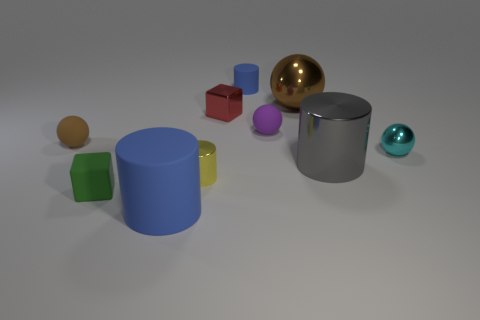Subtract all red cylinders. Subtract all cyan spheres. How many cylinders are left? 4 Subtract all spheres. How many objects are left? 6 Add 3 big cyan metallic objects. How many big cyan metallic objects exist? 3 Subtract 0 purple cubes. How many objects are left? 10 Subtract all rubber blocks. Subtract all small blue rubber cylinders. How many objects are left? 8 Add 2 yellow shiny cylinders. How many yellow shiny cylinders are left? 3 